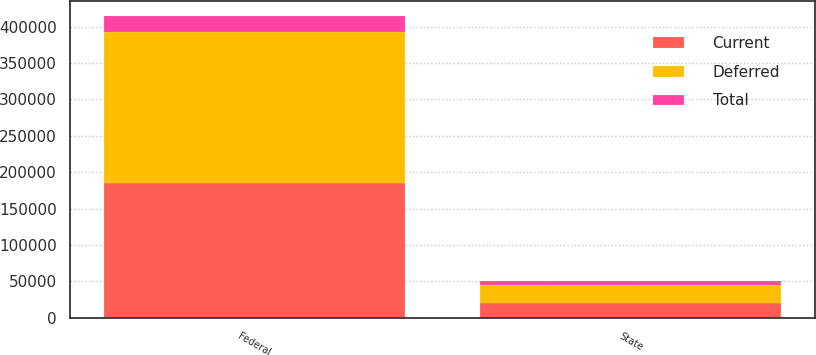<chart> <loc_0><loc_0><loc_500><loc_500><stacked_bar_chart><ecel><fcel>Federal<fcel>State<nl><fcel>Current<fcel>185564<fcel>20116<nl><fcel>Total<fcel>21940<fcel>4953<nl><fcel>Deferred<fcel>207504<fcel>25069<nl></chart> 